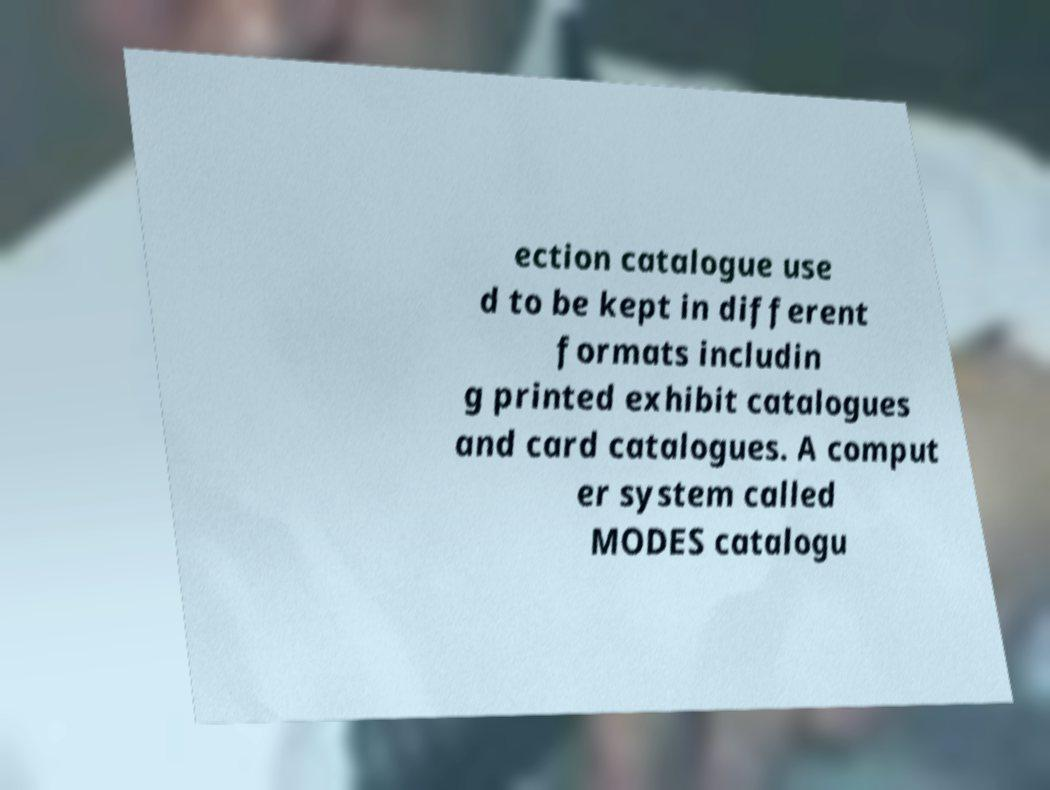Please identify and transcribe the text found in this image. ection catalogue use d to be kept in different formats includin g printed exhibit catalogues and card catalogues. A comput er system called MODES catalogu 